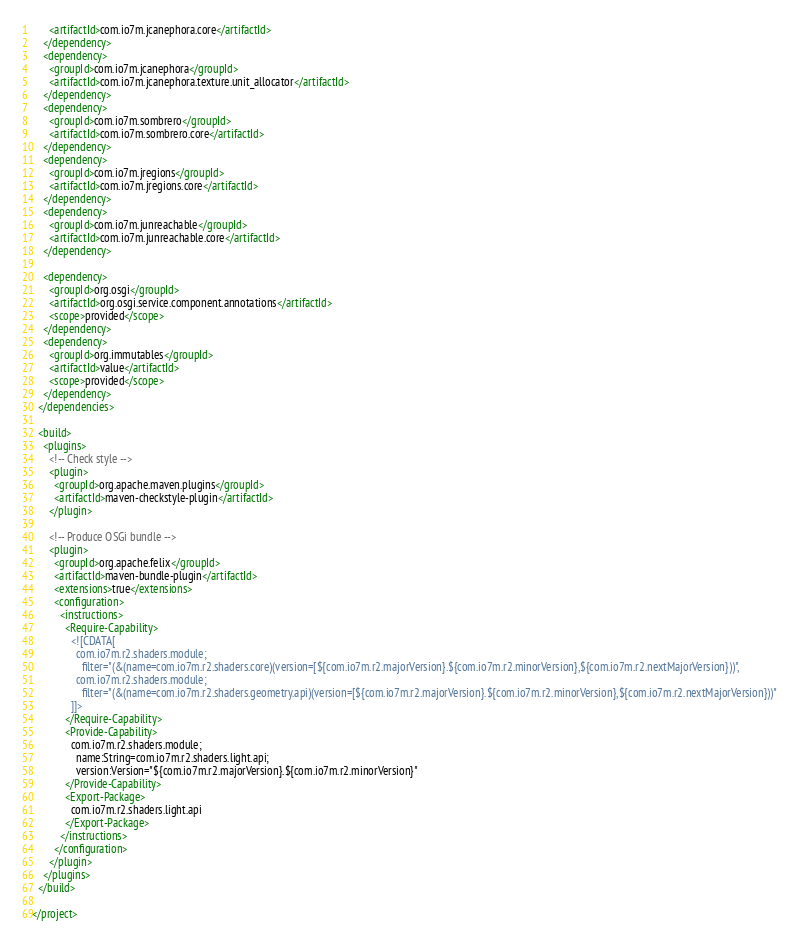<code> <loc_0><loc_0><loc_500><loc_500><_XML_>      <artifactId>com.io7m.jcanephora.core</artifactId>
    </dependency>
    <dependency>
      <groupId>com.io7m.jcanephora</groupId>
      <artifactId>com.io7m.jcanephora.texture.unit_allocator</artifactId>
    </dependency>
    <dependency>
      <groupId>com.io7m.sombrero</groupId>
      <artifactId>com.io7m.sombrero.core</artifactId>
    </dependency>
    <dependency>
      <groupId>com.io7m.jregions</groupId>
      <artifactId>com.io7m.jregions.core</artifactId>
    </dependency>
    <dependency>
      <groupId>com.io7m.junreachable</groupId>
      <artifactId>com.io7m.junreachable.core</artifactId>
    </dependency>

    <dependency>
      <groupId>org.osgi</groupId>
      <artifactId>org.osgi.service.component.annotations</artifactId>
      <scope>provided</scope>
    </dependency>
    <dependency>
      <groupId>org.immutables</groupId>
      <artifactId>value</artifactId>
      <scope>provided</scope>
    </dependency>
  </dependencies>

  <build>
    <plugins>
      <!-- Check style -->
      <plugin>
        <groupId>org.apache.maven.plugins</groupId>
        <artifactId>maven-checkstyle-plugin</artifactId>
      </plugin>

      <!-- Produce OSGi bundle -->
      <plugin>
        <groupId>org.apache.felix</groupId>
        <artifactId>maven-bundle-plugin</artifactId>
        <extensions>true</extensions>
        <configuration>
          <instructions>
            <Require-Capability>
              <![CDATA[
                com.io7m.r2.shaders.module;
                  filter="(&(name=com.io7m.r2.shaders.core)(version=[${com.io7m.r2.majorVersion}.${com.io7m.r2.minorVersion},${com.io7m.r2.nextMajorVersion}))",
                com.io7m.r2.shaders.module;
                  filter="(&(name=com.io7m.r2.shaders.geometry.api)(version=[${com.io7m.r2.majorVersion}.${com.io7m.r2.minorVersion},${com.io7m.r2.nextMajorVersion}))"
              ]]>
            </Require-Capability>
            <Provide-Capability>
              com.io7m.r2.shaders.module;
                name:String=com.io7m.r2.shaders.light.api;
                version:Version="${com.io7m.r2.majorVersion}.${com.io7m.r2.minorVersion}"
            </Provide-Capability>
            <Export-Package>
              com.io7m.r2.shaders.light.api
            </Export-Package>
          </instructions>
        </configuration>
      </plugin>
    </plugins>
  </build>

</project>
</code> 